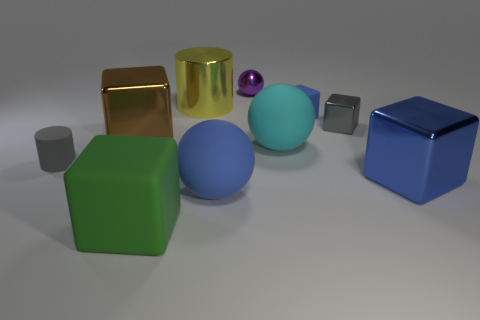Subtract all green blocks. How many blocks are left? 4 Subtract all small gray metallic blocks. How many blocks are left? 4 Subtract all red cubes. Subtract all red cylinders. How many cubes are left? 5 Subtract all balls. How many objects are left? 7 Add 8 yellow cylinders. How many yellow cylinders are left? 9 Add 6 big gray things. How many big gray things exist? 6 Subtract 1 brown cubes. How many objects are left? 9 Subtract all cyan rubber things. Subtract all rubber cylinders. How many objects are left? 8 